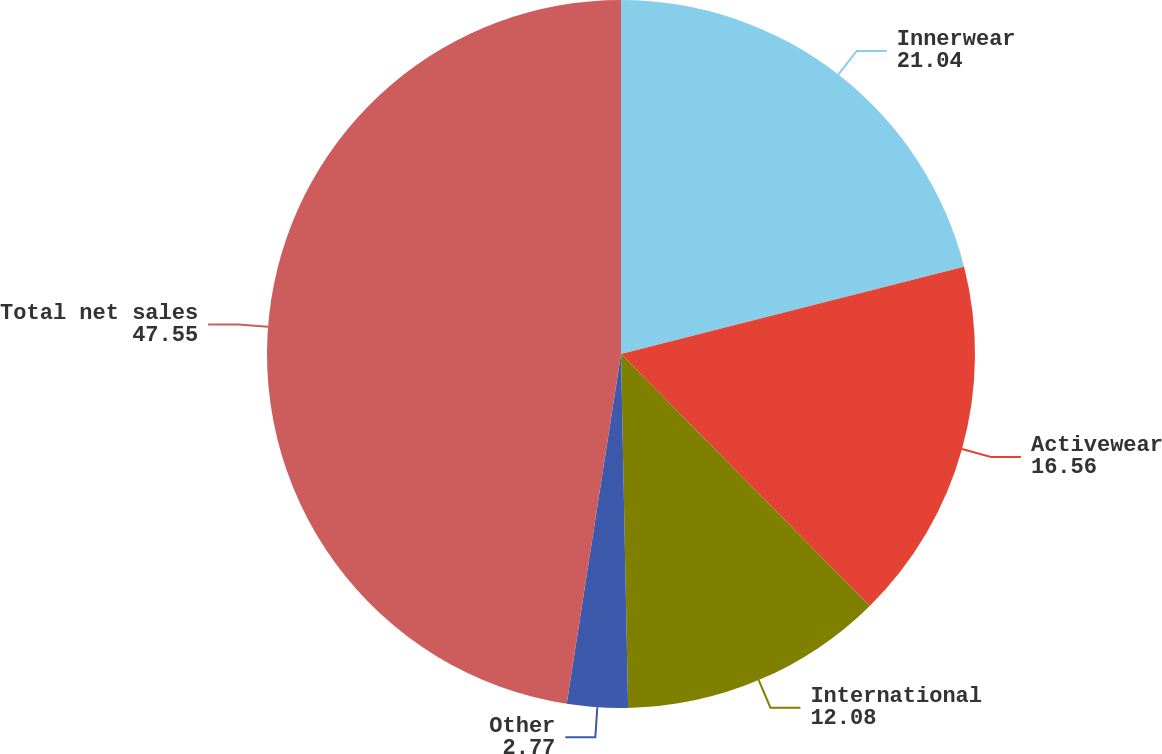Convert chart to OTSL. <chart><loc_0><loc_0><loc_500><loc_500><pie_chart><fcel>Innerwear<fcel>Activewear<fcel>International<fcel>Other<fcel>Total net sales<nl><fcel>21.04%<fcel>16.56%<fcel>12.08%<fcel>2.77%<fcel>47.55%<nl></chart> 